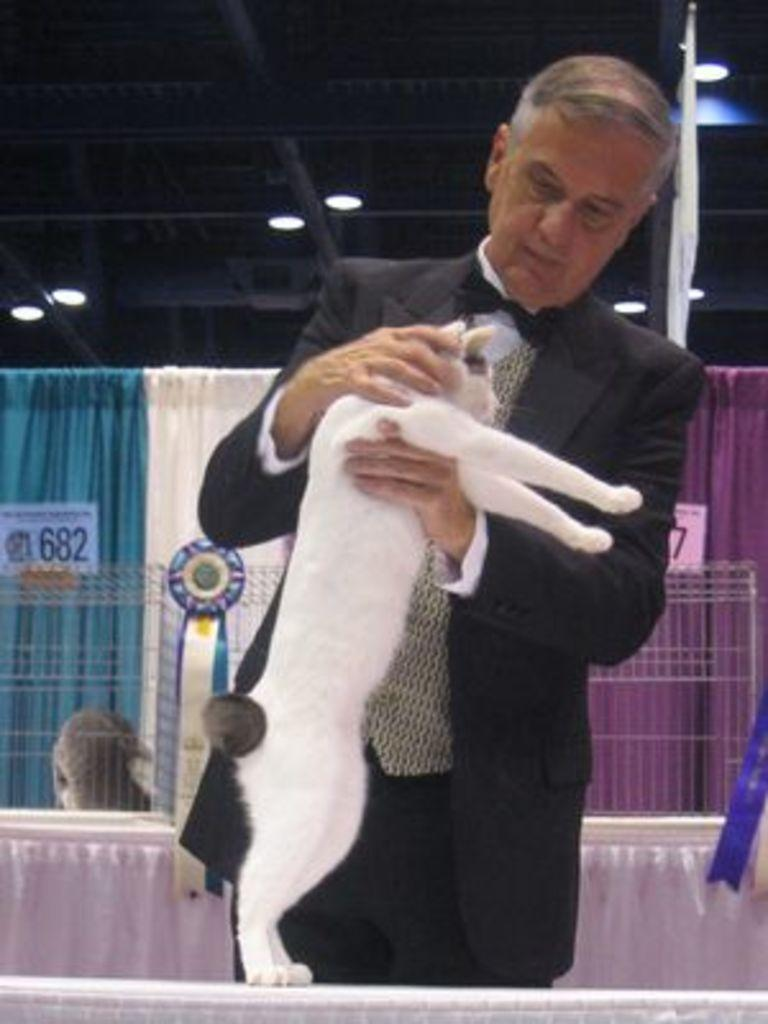What is the main subject in the middle of the image? There is a man standing in the middle of the image. What is the man holding in the image? The man is holding a cat. What can be seen behind the man in the image? There is a banner behind the man. What architectural feature is visible at the top of the image? The top of the image contains a roof. What can be seen illuminating the top of the image? Lights are visible at the top of the image. How many boys are visible in the image? There is no boy present in the image; it features a man holding a cat. What type of market is depicted in the image? There is no market present in the image; it features a man holding a cat with a banner behind him. 